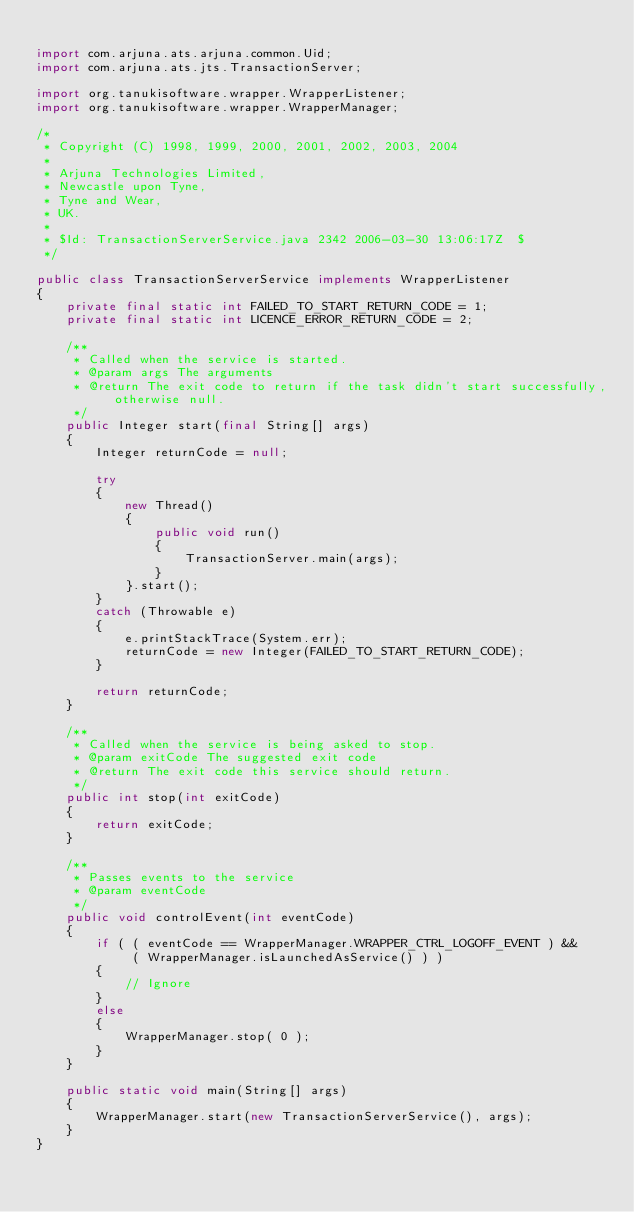Convert code to text. <code><loc_0><loc_0><loc_500><loc_500><_Java_>
import com.arjuna.ats.arjuna.common.Uid;
import com.arjuna.ats.jts.TransactionServer;

import org.tanukisoftware.wrapper.WrapperListener;
import org.tanukisoftware.wrapper.WrapperManager;

/*
 * Copyright (C) 1998, 1999, 2000, 2001, 2002, 2003, 2004
 *
 * Arjuna Technologies Limited,
 * Newcastle upon Tyne,
 * Tyne and Wear,
 * UK.
 *
 * $Id: TransactionServerService.java 2342 2006-03-30 13:06:17Z  $
 */

public class TransactionServerService implements WrapperListener
{
    private final static int FAILED_TO_START_RETURN_CODE = 1;
    private final static int LICENCE_ERROR_RETURN_CODE = 2;

    /**
     * Called when the service is started.
     * @param args The arguments
     * @return The exit code to return if the task didn't start successfully, otherwise null.
     */
    public Integer start(final String[] args)
    {
        Integer returnCode = null;

        try
        {
            new Thread()
            {
                public void run()
                {
                    TransactionServer.main(args);
                }
            }.start();
        }
        catch (Throwable e)
        {
            e.printStackTrace(System.err);
            returnCode = new Integer(FAILED_TO_START_RETURN_CODE);
        }

        return returnCode;
    }

    /**
     * Called when the service is being asked to stop.
     * @param exitCode The suggested exit code
     * @return The exit code this service should return.
     */
    public int stop(int exitCode)
    {
        return exitCode;
    }

    /**
     * Passes events to the service
     * @param eventCode
     */
    public void controlEvent(int eventCode)
    {
        if ( ( eventCode == WrapperManager.WRAPPER_CTRL_LOGOFF_EVENT ) &&
             ( WrapperManager.isLaunchedAsService() ) )
        {
            // Ignore
        }
        else
        {
            WrapperManager.stop( 0 );
        }
    }

    public static void main(String[] args)
    {
        WrapperManager.start(new TransactionServerService(), args);
    }
}
</code> 